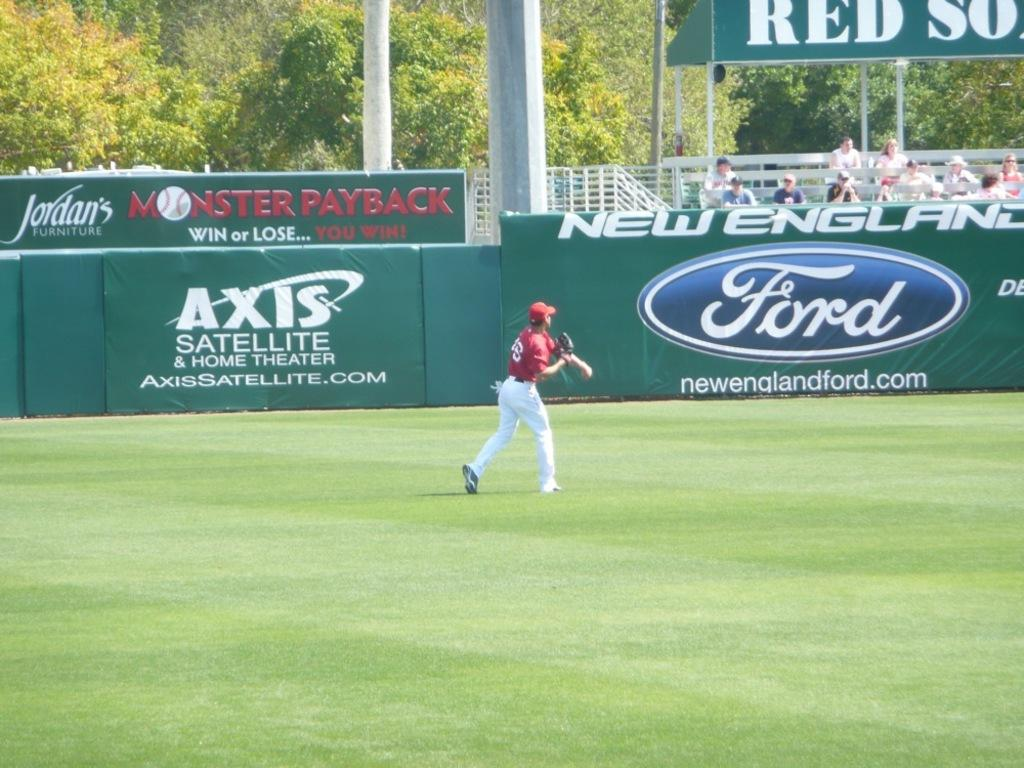<image>
Provide a brief description of the given image. A baseball game is being played at a stadium which is sponsored by Ford. 